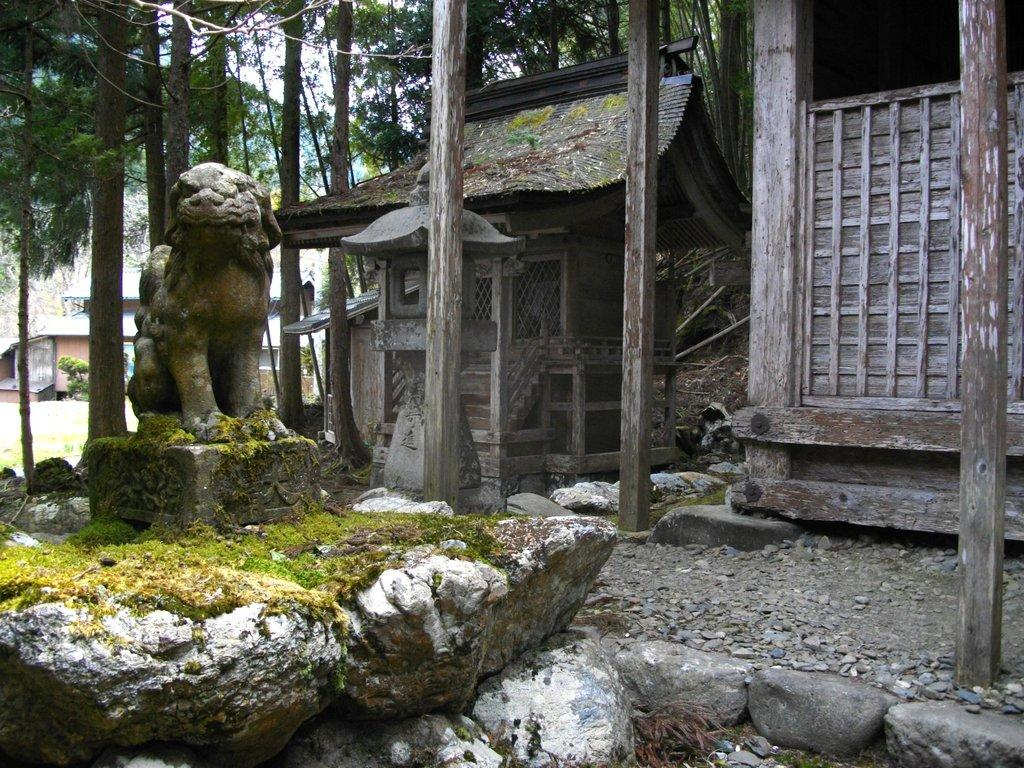What is the main subject in the image? There is a statue in the image. What is the statue standing on? The statue is on an animal and a rock. Where is the vintage home located in the image? The vintage home is on the right side of the image. What can be seen behind the vintage home? Trees are visible behind the vintage home. What grade of shock can be seen on the line in the image? There is no line or shock present in the image. 